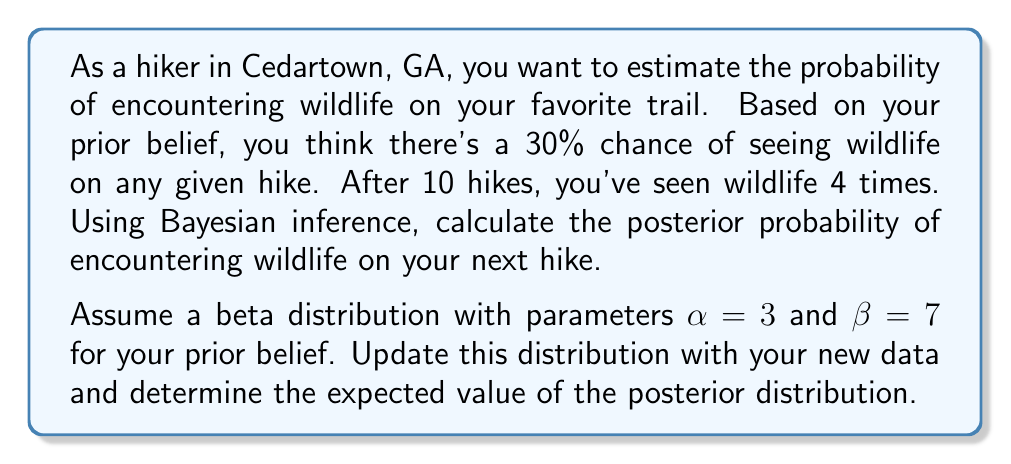Can you answer this question? Let's approach this step-by-step using Bayesian inference:

1) Prior distribution:
   We're using a beta distribution with $\alpha=3$ and $\beta=7$. This reflects our prior belief of a 30% chance of seeing wildlife, as $\frac{\alpha}{\alpha+\beta} = \frac{3}{3+7} = 0.3$.

2) Likelihood:
   We observed 4 successes (wildlife sightings) out of 10 trials (hikes).

3) Posterior distribution:
   The beta distribution is conjugate to the binomial likelihood, so our posterior will also be a beta distribution.
   
   The parameters of the posterior beta distribution are:
   $$\alpha_{posterior} = \alpha_{prior} + \text{successes} = 3 + 4 = 7$$
   $$\beta_{posterior} = \beta_{prior} + \text{failures} = 7 + (10-4) = 13$$

4) Expected value of the posterior distribution:
   For a beta distribution, the expected value is given by:
   $$E(X) = \frac{\alpha}{\alpha + \beta}$$

   Substituting our posterior parameters:
   $$E(X) = \frac{\alpha_{posterior}}{\alpha_{posterior} + \beta_{posterior}} = \frac{7}{7 + 13} = \frac{7}{20} = 0.35$$

Therefore, based on our prior belief and the new data, the expected probability of encountering wildlife on the next hike is 0.35 or 35%.
Answer: 0.35 